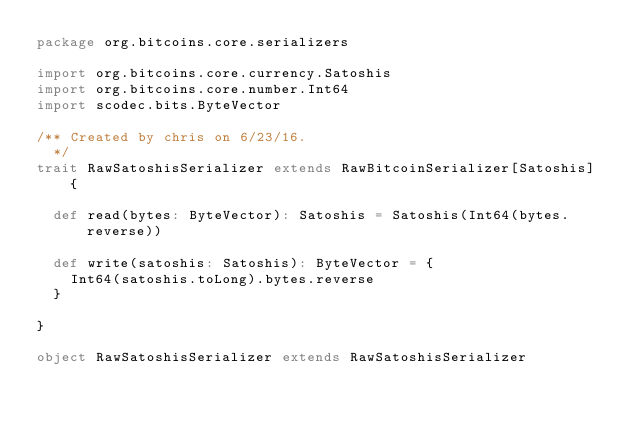<code> <loc_0><loc_0><loc_500><loc_500><_Scala_>package org.bitcoins.core.serializers

import org.bitcoins.core.currency.Satoshis
import org.bitcoins.core.number.Int64
import scodec.bits.ByteVector

/** Created by chris on 6/23/16.
  */
trait RawSatoshisSerializer extends RawBitcoinSerializer[Satoshis] {

  def read(bytes: ByteVector): Satoshis = Satoshis(Int64(bytes.reverse))

  def write(satoshis: Satoshis): ByteVector = {
    Int64(satoshis.toLong).bytes.reverse
  }

}

object RawSatoshisSerializer extends RawSatoshisSerializer
</code> 